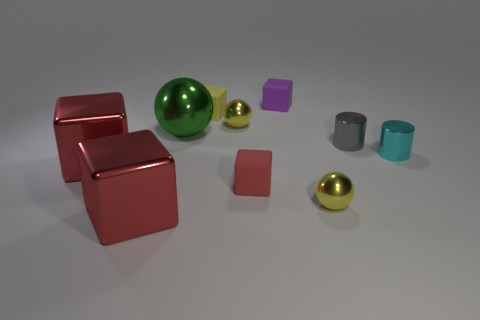There is another shiny object that is the same shape as the gray object; what is its size?
Offer a terse response. Small. The cube that is both in front of the purple cube and behind the big green shiny object is made of what material?
Provide a succinct answer. Rubber. There is a shiny cylinder on the left side of the cyan object; does it have the same color as the large shiny sphere?
Ensure brevity in your answer.  No. There is a large shiny ball; is its color the same as the matte thing in front of the green ball?
Your answer should be very brief. No. Are there any shiny things on the left side of the gray metal cylinder?
Ensure brevity in your answer.  Yes. Is the cyan cylinder made of the same material as the tiny yellow block?
Your answer should be very brief. No. What material is the purple cube that is the same size as the cyan shiny object?
Your response must be concise. Rubber. What number of objects are rubber cubes that are in front of the yellow cube or yellow metal spheres?
Your answer should be very brief. 3. Are there an equal number of small metallic cylinders behind the red rubber cube and rubber objects?
Offer a very short reply. No. The tiny object that is both right of the tiny red cube and behind the gray thing is what color?
Your response must be concise. Purple. 